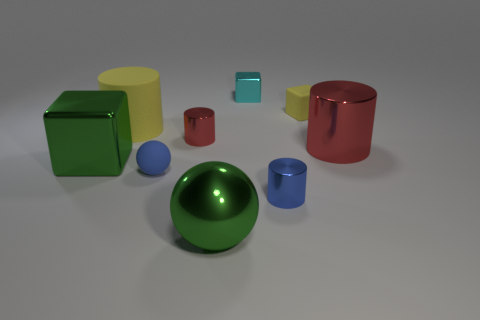Subtract 1 cylinders. How many cylinders are left? 3 Add 1 tiny rubber objects. How many objects exist? 10 Subtract all cubes. How many objects are left? 6 Subtract 0 brown spheres. How many objects are left? 9 Subtract all tiny yellow blocks. Subtract all small blue rubber spheres. How many objects are left? 7 Add 1 cylinders. How many cylinders are left? 5 Add 8 blue metal things. How many blue metal things exist? 9 